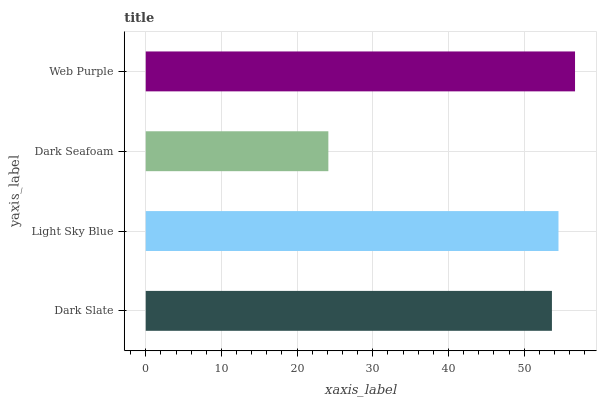Is Dark Seafoam the minimum?
Answer yes or no. Yes. Is Web Purple the maximum?
Answer yes or no. Yes. Is Light Sky Blue the minimum?
Answer yes or no. No. Is Light Sky Blue the maximum?
Answer yes or no. No. Is Light Sky Blue greater than Dark Slate?
Answer yes or no. Yes. Is Dark Slate less than Light Sky Blue?
Answer yes or no. Yes. Is Dark Slate greater than Light Sky Blue?
Answer yes or no. No. Is Light Sky Blue less than Dark Slate?
Answer yes or no. No. Is Light Sky Blue the high median?
Answer yes or no. Yes. Is Dark Slate the low median?
Answer yes or no. Yes. Is Dark Slate the high median?
Answer yes or no. No. Is Light Sky Blue the low median?
Answer yes or no. No. 